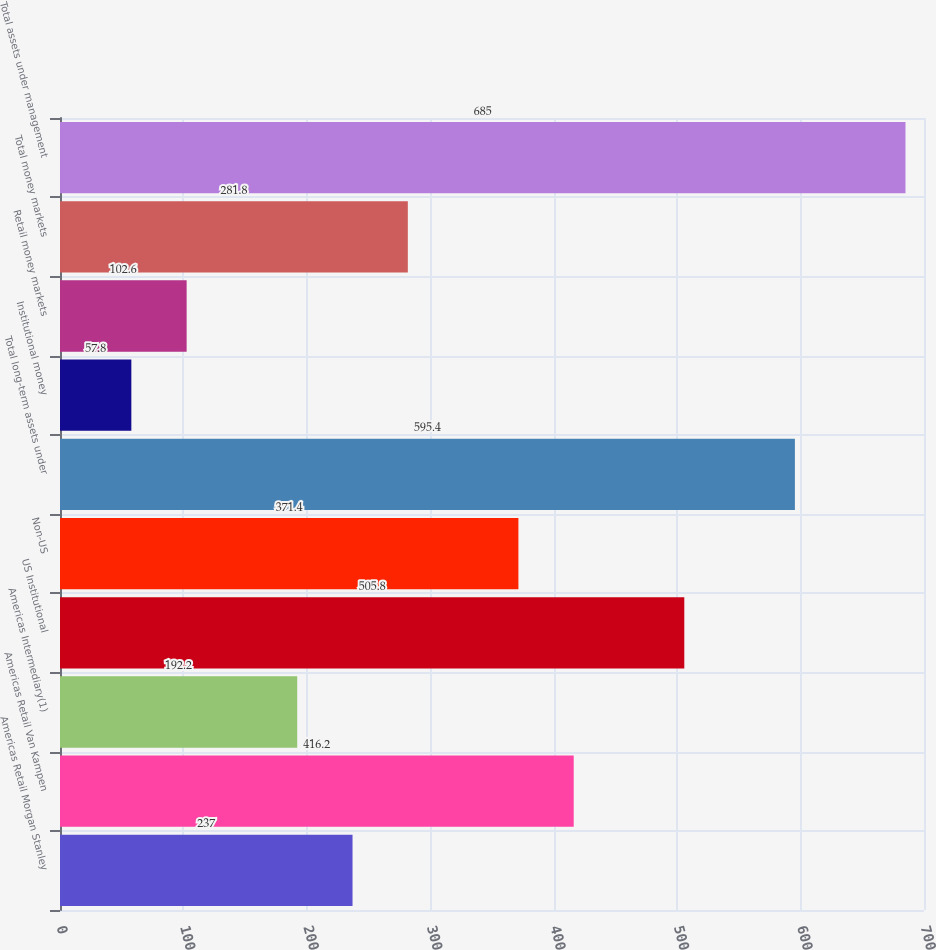<chart> <loc_0><loc_0><loc_500><loc_500><bar_chart><fcel>Americas Retail Morgan Stanley<fcel>Americas Retail Van Kampen<fcel>Americas Intermediary(1)<fcel>US Institutional<fcel>Non-US<fcel>Total long-term assets under<fcel>Institutional money<fcel>Retail money markets<fcel>Total money markets<fcel>Total assets under management<nl><fcel>237<fcel>416.2<fcel>192.2<fcel>505.8<fcel>371.4<fcel>595.4<fcel>57.8<fcel>102.6<fcel>281.8<fcel>685<nl></chart> 